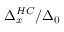Convert formula to latex. <formula><loc_0><loc_0><loc_500><loc_500>\Delta _ { x } ^ { H C } / \Delta _ { 0 }</formula> 